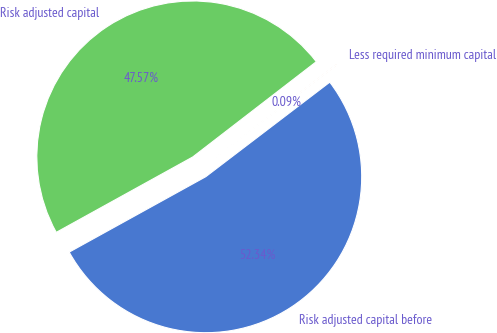<chart> <loc_0><loc_0><loc_500><loc_500><pie_chart><fcel>Risk adjusted capital before<fcel>Less required minimum capital<fcel>Risk adjusted capital<nl><fcel>52.33%<fcel>0.09%<fcel>47.57%<nl></chart> 